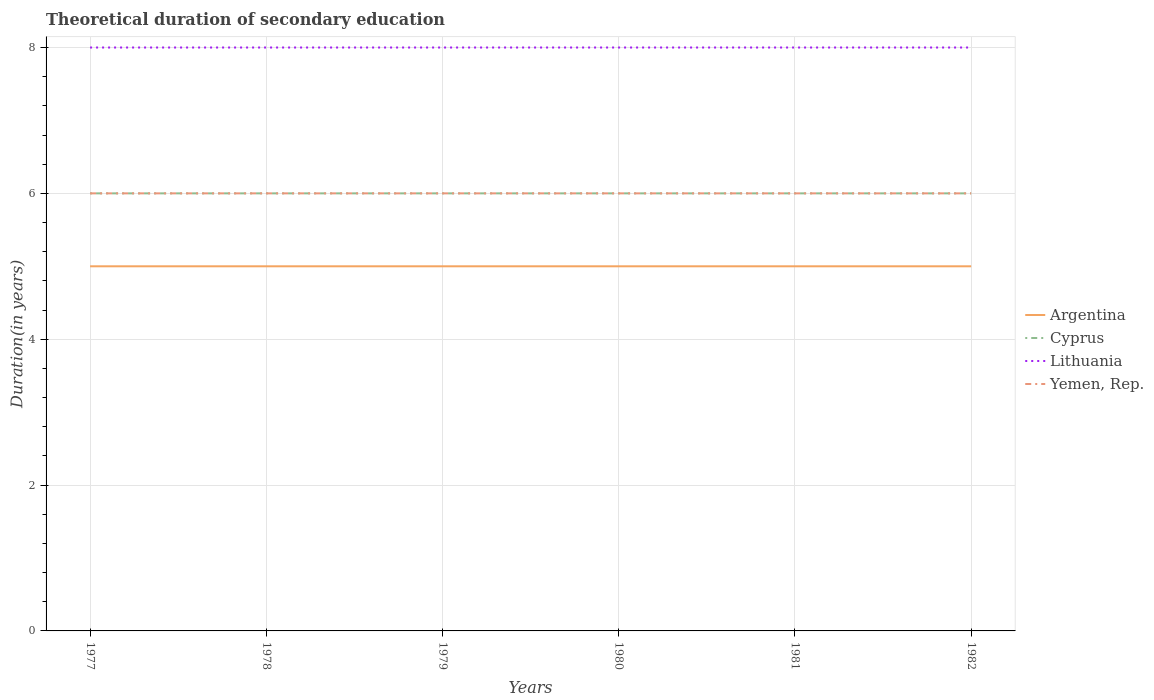How many different coloured lines are there?
Your answer should be compact. 4. Is the number of lines equal to the number of legend labels?
Your answer should be compact. Yes. What is the total total theoretical duration of secondary education in Lithuania in the graph?
Offer a very short reply. 0. Are the values on the major ticks of Y-axis written in scientific E-notation?
Your answer should be compact. No. Does the graph contain any zero values?
Keep it short and to the point. No. Does the graph contain grids?
Ensure brevity in your answer.  Yes. How many legend labels are there?
Ensure brevity in your answer.  4. How are the legend labels stacked?
Give a very brief answer. Vertical. What is the title of the graph?
Give a very brief answer. Theoretical duration of secondary education. Does "Gambia, The" appear as one of the legend labels in the graph?
Provide a short and direct response. No. What is the label or title of the Y-axis?
Your response must be concise. Duration(in years). What is the Duration(in years) in Argentina in 1977?
Provide a short and direct response. 5. What is the Duration(in years) of Lithuania in 1978?
Keep it short and to the point. 8. What is the Duration(in years) of Cyprus in 1979?
Keep it short and to the point. 6. What is the Duration(in years) in Lithuania in 1979?
Keep it short and to the point. 8. What is the Duration(in years) in Cyprus in 1980?
Make the answer very short. 6. What is the Duration(in years) of Yemen, Rep. in 1980?
Give a very brief answer. 6. What is the Duration(in years) of Lithuania in 1981?
Ensure brevity in your answer.  8. What is the Duration(in years) in Yemen, Rep. in 1981?
Provide a succinct answer. 6. What is the Duration(in years) in Argentina in 1982?
Your answer should be compact. 5. What is the Duration(in years) in Lithuania in 1982?
Offer a very short reply. 8. Across all years, what is the maximum Duration(in years) in Argentina?
Offer a very short reply. 5. Across all years, what is the maximum Duration(in years) of Cyprus?
Keep it short and to the point. 6. Across all years, what is the maximum Duration(in years) of Lithuania?
Offer a very short reply. 8. Across all years, what is the maximum Duration(in years) of Yemen, Rep.?
Your response must be concise. 6. Across all years, what is the minimum Duration(in years) in Cyprus?
Make the answer very short. 6. Across all years, what is the minimum Duration(in years) of Yemen, Rep.?
Offer a very short reply. 6. What is the total Duration(in years) in Lithuania in the graph?
Offer a terse response. 48. What is the difference between the Duration(in years) of Argentina in 1977 and that in 1978?
Make the answer very short. 0. What is the difference between the Duration(in years) in Cyprus in 1977 and that in 1978?
Offer a terse response. 0. What is the difference between the Duration(in years) of Yemen, Rep. in 1977 and that in 1978?
Your response must be concise. 0. What is the difference between the Duration(in years) in Argentina in 1977 and that in 1979?
Keep it short and to the point. 0. What is the difference between the Duration(in years) of Cyprus in 1977 and that in 1979?
Provide a short and direct response. 0. What is the difference between the Duration(in years) of Argentina in 1977 and that in 1980?
Ensure brevity in your answer.  0. What is the difference between the Duration(in years) in Cyprus in 1977 and that in 1980?
Give a very brief answer. 0. What is the difference between the Duration(in years) of Argentina in 1977 and that in 1981?
Offer a terse response. 0. What is the difference between the Duration(in years) of Lithuania in 1977 and that in 1981?
Your answer should be very brief. 0. What is the difference between the Duration(in years) in Yemen, Rep. in 1977 and that in 1981?
Offer a very short reply. 0. What is the difference between the Duration(in years) of Lithuania in 1977 and that in 1982?
Offer a very short reply. 0. What is the difference between the Duration(in years) of Argentina in 1978 and that in 1979?
Make the answer very short. 0. What is the difference between the Duration(in years) in Cyprus in 1978 and that in 1979?
Your answer should be very brief. 0. What is the difference between the Duration(in years) of Argentina in 1978 and that in 1980?
Make the answer very short. 0. What is the difference between the Duration(in years) in Lithuania in 1978 and that in 1980?
Offer a very short reply. 0. What is the difference between the Duration(in years) in Yemen, Rep. in 1978 and that in 1980?
Keep it short and to the point. 0. What is the difference between the Duration(in years) in Argentina in 1978 and that in 1982?
Ensure brevity in your answer.  0. What is the difference between the Duration(in years) of Cyprus in 1978 and that in 1982?
Make the answer very short. 0. What is the difference between the Duration(in years) in Yemen, Rep. in 1978 and that in 1982?
Ensure brevity in your answer.  0. What is the difference between the Duration(in years) in Argentina in 1979 and that in 1980?
Make the answer very short. 0. What is the difference between the Duration(in years) in Lithuania in 1979 and that in 1980?
Ensure brevity in your answer.  0. What is the difference between the Duration(in years) of Yemen, Rep. in 1979 and that in 1981?
Make the answer very short. 0. What is the difference between the Duration(in years) of Lithuania in 1979 and that in 1982?
Offer a very short reply. 0. What is the difference between the Duration(in years) in Yemen, Rep. in 1979 and that in 1982?
Keep it short and to the point. 0. What is the difference between the Duration(in years) in Argentina in 1980 and that in 1981?
Keep it short and to the point. 0. What is the difference between the Duration(in years) in Lithuania in 1980 and that in 1981?
Offer a terse response. 0. What is the difference between the Duration(in years) of Lithuania in 1980 and that in 1982?
Ensure brevity in your answer.  0. What is the difference between the Duration(in years) in Argentina in 1981 and that in 1982?
Make the answer very short. 0. What is the difference between the Duration(in years) of Lithuania in 1981 and that in 1982?
Make the answer very short. 0. What is the difference between the Duration(in years) in Argentina in 1977 and the Duration(in years) in Cyprus in 1978?
Give a very brief answer. -1. What is the difference between the Duration(in years) of Argentina in 1977 and the Duration(in years) of Lithuania in 1978?
Your answer should be very brief. -3. What is the difference between the Duration(in years) in Argentina in 1977 and the Duration(in years) in Yemen, Rep. in 1978?
Provide a short and direct response. -1. What is the difference between the Duration(in years) of Argentina in 1977 and the Duration(in years) of Cyprus in 1979?
Keep it short and to the point. -1. What is the difference between the Duration(in years) in Argentina in 1977 and the Duration(in years) in Lithuania in 1979?
Keep it short and to the point. -3. What is the difference between the Duration(in years) in Cyprus in 1977 and the Duration(in years) in Lithuania in 1979?
Your answer should be very brief. -2. What is the difference between the Duration(in years) of Cyprus in 1977 and the Duration(in years) of Yemen, Rep. in 1979?
Give a very brief answer. 0. What is the difference between the Duration(in years) in Argentina in 1977 and the Duration(in years) in Lithuania in 1980?
Give a very brief answer. -3. What is the difference between the Duration(in years) in Argentina in 1977 and the Duration(in years) in Yemen, Rep. in 1980?
Offer a terse response. -1. What is the difference between the Duration(in years) in Cyprus in 1977 and the Duration(in years) in Lithuania in 1980?
Offer a terse response. -2. What is the difference between the Duration(in years) of Lithuania in 1977 and the Duration(in years) of Yemen, Rep. in 1980?
Offer a very short reply. 2. What is the difference between the Duration(in years) in Argentina in 1977 and the Duration(in years) in Yemen, Rep. in 1981?
Offer a very short reply. -1. What is the difference between the Duration(in years) of Cyprus in 1977 and the Duration(in years) of Lithuania in 1981?
Your answer should be compact. -2. What is the difference between the Duration(in years) of Argentina in 1977 and the Duration(in years) of Lithuania in 1982?
Offer a very short reply. -3. What is the difference between the Duration(in years) in Argentina in 1977 and the Duration(in years) in Yemen, Rep. in 1982?
Keep it short and to the point. -1. What is the difference between the Duration(in years) of Lithuania in 1977 and the Duration(in years) of Yemen, Rep. in 1982?
Give a very brief answer. 2. What is the difference between the Duration(in years) in Argentina in 1978 and the Duration(in years) in Lithuania in 1979?
Give a very brief answer. -3. What is the difference between the Duration(in years) of Argentina in 1978 and the Duration(in years) of Yemen, Rep. in 1979?
Offer a very short reply. -1. What is the difference between the Duration(in years) in Cyprus in 1978 and the Duration(in years) in Lithuania in 1979?
Give a very brief answer. -2. What is the difference between the Duration(in years) of Argentina in 1978 and the Duration(in years) of Cyprus in 1980?
Your answer should be compact. -1. What is the difference between the Duration(in years) of Argentina in 1978 and the Duration(in years) of Lithuania in 1980?
Ensure brevity in your answer.  -3. What is the difference between the Duration(in years) in Cyprus in 1978 and the Duration(in years) in Lithuania in 1980?
Your answer should be compact. -2. What is the difference between the Duration(in years) of Lithuania in 1978 and the Duration(in years) of Yemen, Rep. in 1980?
Provide a short and direct response. 2. What is the difference between the Duration(in years) of Cyprus in 1978 and the Duration(in years) of Yemen, Rep. in 1981?
Your answer should be very brief. 0. What is the difference between the Duration(in years) of Lithuania in 1978 and the Duration(in years) of Yemen, Rep. in 1981?
Your response must be concise. 2. What is the difference between the Duration(in years) of Argentina in 1978 and the Duration(in years) of Cyprus in 1982?
Ensure brevity in your answer.  -1. What is the difference between the Duration(in years) of Argentina in 1978 and the Duration(in years) of Lithuania in 1982?
Your answer should be very brief. -3. What is the difference between the Duration(in years) of Argentina in 1978 and the Duration(in years) of Yemen, Rep. in 1982?
Make the answer very short. -1. What is the difference between the Duration(in years) of Lithuania in 1978 and the Duration(in years) of Yemen, Rep. in 1982?
Offer a very short reply. 2. What is the difference between the Duration(in years) of Argentina in 1979 and the Duration(in years) of Lithuania in 1980?
Make the answer very short. -3. What is the difference between the Duration(in years) in Argentina in 1979 and the Duration(in years) in Yemen, Rep. in 1980?
Your answer should be very brief. -1. What is the difference between the Duration(in years) in Cyprus in 1979 and the Duration(in years) in Yemen, Rep. in 1980?
Your answer should be compact. 0. What is the difference between the Duration(in years) of Lithuania in 1979 and the Duration(in years) of Yemen, Rep. in 1980?
Your response must be concise. 2. What is the difference between the Duration(in years) in Argentina in 1979 and the Duration(in years) in Cyprus in 1981?
Offer a very short reply. -1. What is the difference between the Duration(in years) of Argentina in 1979 and the Duration(in years) of Yemen, Rep. in 1981?
Provide a succinct answer. -1. What is the difference between the Duration(in years) of Cyprus in 1979 and the Duration(in years) of Yemen, Rep. in 1981?
Keep it short and to the point. 0. What is the difference between the Duration(in years) of Lithuania in 1979 and the Duration(in years) of Yemen, Rep. in 1981?
Your response must be concise. 2. What is the difference between the Duration(in years) in Argentina in 1979 and the Duration(in years) in Cyprus in 1982?
Make the answer very short. -1. What is the difference between the Duration(in years) in Argentina in 1979 and the Duration(in years) in Lithuania in 1982?
Offer a terse response. -3. What is the difference between the Duration(in years) in Lithuania in 1979 and the Duration(in years) in Yemen, Rep. in 1982?
Offer a terse response. 2. What is the difference between the Duration(in years) in Argentina in 1980 and the Duration(in years) in Lithuania in 1981?
Ensure brevity in your answer.  -3. What is the difference between the Duration(in years) of Argentina in 1980 and the Duration(in years) of Yemen, Rep. in 1981?
Provide a succinct answer. -1. What is the difference between the Duration(in years) of Cyprus in 1980 and the Duration(in years) of Yemen, Rep. in 1981?
Give a very brief answer. 0. What is the difference between the Duration(in years) in Lithuania in 1980 and the Duration(in years) in Yemen, Rep. in 1981?
Provide a succinct answer. 2. What is the difference between the Duration(in years) in Argentina in 1980 and the Duration(in years) in Yemen, Rep. in 1982?
Make the answer very short. -1. What is the difference between the Duration(in years) of Cyprus in 1980 and the Duration(in years) of Lithuania in 1982?
Make the answer very short. -2. What is the difference between the Duration(in years) in Lithuania in 1980 and the Duration(in years) in Yemen, Rep. in 1982?
Your response must be concise. 2. What is the difference between the Duration(in years) of Argentina in 1981 and the Duration(in years) of Cyprus in 1982?
Offer a very short reply. -1. What is the difference between the Duration(in years) in Cyprus in 1981 and the Duration(in years) in Lithuania in 1982?
Give a very brief answer. -2. What is the average Duration(in years) in Argentina per year?
Provide a succinct answer. 5. What is the average Duration(in years) of Cyprus per year?
Offer a very short reply. 6. What is the average Duration(in years) in Lithuania per year?
Provide a short and direct response. 8. In the year 1977, what is the difference between the Duration(in years) of Argentina and Duration(in years) of Cyprus?
Provide a short and direct response. -1. In the year 1977, what is the difference between the Duration(in years) in Argentina and Duration(in years) in Lithuania?
Your answer should be compact. -3. In the year 1977, what is the difference between the Duration(in years) of Argentina and Duration(in years) of Yemen, Rep.?
Provide a succinct answer. -1. In the year 1977, what is the difference between the Duration(in years) of Cyprus and Duration(in years) of Yemen, Rep.?
Make the answer very short. 0. In the year 1977, what is the difference between the Duration(in years) in Lithuania and Duration(in years) in Yemen, Rep.?
Make the answer very short. 2. In the year 1978, what is the difference between the Duration(in years) in Argentina and Duration(in years) in Cyprus?
Keep it short and to the point. -1. In the year 1978, what is the difference between the Duration(in years) of Cyprus and Duration(in years) of Lithuania?
Keep it short and to the point. -2. In the year 1978, what is the difference between the Duration(in years) of Lithuania and Duration(in years) of Yemen, Rep.?
Ensure brevity in your answer.  2. In the year 1979, what is the difference between the Duration(in years) in Argentina and Duration(in years) in Cyprus?
Ensure brevity in your answer.  -1. In the year 1979, what is the difference between the Duration(in years) in Argentina and Duration(in years) in Lithuania?
Ensure brevity in your answer.  -3. In the year 1979, what is the difference between the Duration(in years) in Cyprus and Duration(in years) in Lithuania?
Your answer should be very brief. -2. In the year 1979, what is the difference between the Duration(in years) of Cyprus and Duration(in years) of Yemen, Rep.?
Give a very brief answer. 0. In the year 1979, what is the difference between the Duration(in years) of Lithuania and Duration(in years) of Yemen, Rep.?
Your answer should be compact. 2. In the year 1980, what is the difference between the Duration(in years) of Cyprus and Duration(in years) of Lithuania?
Make the answer very short. -2. In the year 1980, what is the difference between the Duration(in years) in Cyprus and Duration(in years) in Yemen, Rep.?
Give a very brief answer. 0. In the year 1981, what is the difference between the Duration(in years) of Cyprus and Duration(in years) of Yemen, Rep.?
Offer a terse response. 0. In the year 1982, what is the difference between the Duration(in years) in Argentina and Duration(in years) in Yemen, Rep.?
Your answer should be very brief. -1. In the year 1982, what is the difference between the Duration(in years) in Cyprus and Duration(in years) in Lithuania?
Offer a terse response. -2. In the year 1982, what is the difference between the Duration(in years) of Cyprus and Duration(in years) of Yemen, Rep.?
Your answer should be very brief. 0. In the year 1982, what is the difference between the Duration(in years) of Lithuania and Duration(in years) of Yemen, Rep.?
Give a very brief answer. 2. What is the ratio of the Duration(in years) of Cyprus in 1977 to that in 1978?
Ensure brevity in your answer.  1. What is the ratio of the Duration(in years) in Yemen, Rep. in 1977 to that in 1978?
Make the answer very short. 1. What is the ratio of the Duration(in years) in Argentina in 1977 to that in 1980?
Offer a terse response. 1. What is the ratio of the Duration(in years) of Cyprus in 1977 to that in 1980?
Provide a succinct answer. 1. What is the ratio of the Duration(in years) of Argentina in 1977 to that in 1981?
Keep it short and to the point. 1. What is the ratio of the Duration(in years) in Lithuania in 1977 to that in 1981?
Offer a very short reply. 1. What is the ratio of the Duration(in years) in Argentina in 1977 to that in 1982?
Make the answer very short. 1. What is the ratio of the Duration(in years) of Cyprus in 1977 to that in 1982?
Your answer should be compact. 1. What is the ratio of the Duration(in years) in Argentina in 1978 to that in 1979?
Offer a terse response. 1. What is the ratio of the Duration(in years) of Lithuania in 1978 to that in 1979?
Your answer should be compact. 1. What is the ratio of the Duration(in years) of Yemen, Rep. in 1978 to that in 1979?
Offer a very short reply. 1. What is the ratio of the Duration(in years) of Argentina in 1978 to that in 1980?
Give a very brief answer. 1. What is the ratio of the Duration(in years) of Yemen, Rep. in 1978 to that in 1980?
Offer a very short reply. 1. What is the ratio of the Duration(in years) of Cyprus in 1978 to that in 1981?
Give a very brief answer. 1. What is the ratio of the Duration(in years) of Lithuania in 1978 to that in 1982?
Give a very brief answer. 1. What is the ratio of the Duration(in years) in Cyprus in 1979 to that in 1980?
Your response must be concise. 1. What is the ratio of the Duration(in years) in Cyprus in 1979 to that in 1981?
Make the answer very short. 1. What is the ratio of the Duration(in years) of Lithuania in 1979 to that in 1981?
Provide a succinct answer. 1. What is the ratio of the Duration(in years) of Lithuania in 1979 to that in 1982?
Offer a very short reply. 1. What is the ratio of the Duration(in years) in Cyprus in 1980 to that in 1981?
Provide a short and direct response. 1. What is the ratio of the Duration(in years) of Lithuania in 1980 to that in 1981?
Your response must be concise. 1. What is the ratio of the Duration(in years) of Yemen, Rep. in 1980 to that in 1981?
Provide a short and direct response. 1. What is the ratio of the Duration(in years) of Cyprus in 1980 to that in 1982?
Your answer should be compact. 1. What is the ratio of the Duration(in years) of Lithuania in 1980 to that in 1982?
Provide a short and direct response. 1. What is the ratio of the Duration(in years) of Yemen, Rep. in 1980 to that in 1982?
Provide a short and direct response. 1. What is the ratio of the Duration(in years) of Argentina in 1981 to that in 1982?
Your response must be concise. 1. What is the ratio of the Duration(in years) of Cyprus in 1981 to that in 1982?
Provide a succinct answer. 1. What is the ratio of the Duration(in years) of Yemen, Rep. in 1981 to that in 1982?
Offer a terse response. 1. What is the difference between the highest and the second highest Duration(in years) in Cyprus?
Keep it short and to the point. 0. What is the difference between the highest and the second highest Duration(in years) in Lithuania?
Your answer should be compact. 0. What is the difference between the highest and the second highest Duration(in years) in Yemen, Rep.?
Offer a very short reply. 0. What is the difference between the highest and the lowest Duration(in years) in Cyprus?
Your answer should be very brief. 0. What is the difference between the highest and the lowest Duration(in years) in Lithuania?
Provide a short and direct response. 0. 